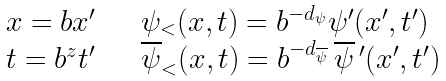Convert formula to latex. <formula><loc_0><loc_0><loc_500><loc_500>\begin{array} { l l } x = b x ^ { \prime } & \quad \psi _ { < } ( x , t ) = b ^ { - d _ { \psi } } \psi ^ { \prime } ( x ^ { \prime } , t ^ { \prime } ) \\ t = b ^ { z } t ^ { \prime } & \quad \overline { \psi } _ { < } ( x , t ) = b ^ { - d _ { \overline { \psi } } } \, \overline { \psi } \, ^ { \prime } ( x ^ { \prime } , t ^ { \prime } ) \end{array}</formula> 